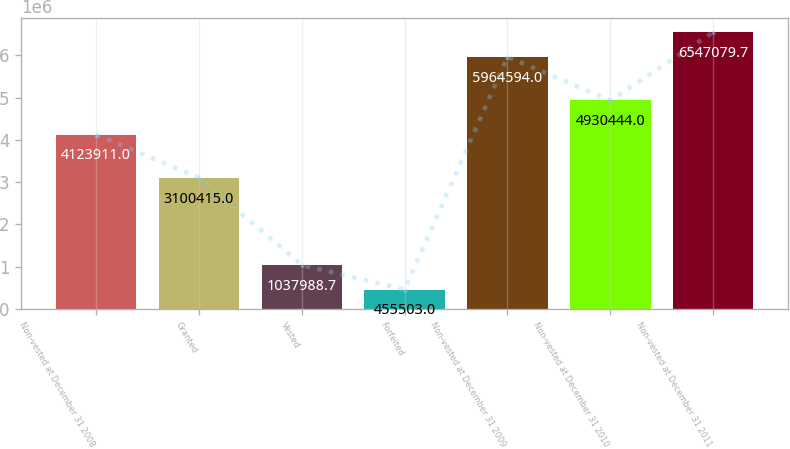Convert chart to OTSL. <chart><loc_0><loc_0><loc_500><loc_500><bar_chart><fcel>Non-vested at December 31 2008<fcel>Granted<fcel>Vested<fcel>Forfeited<fcel>Non-vested at December 31 2009<fcel>Non-vested at December 31 2010<fcel>Non-vested at December 31 2011<nl><fcel>4.12391e+06<fcel>3.10042e+06<fcel>1.03799e+06<fcel>455503<fcel>5.96459e+06<fcel>4.93044e+06<fcel>6.54708e+06<nl></chart> 